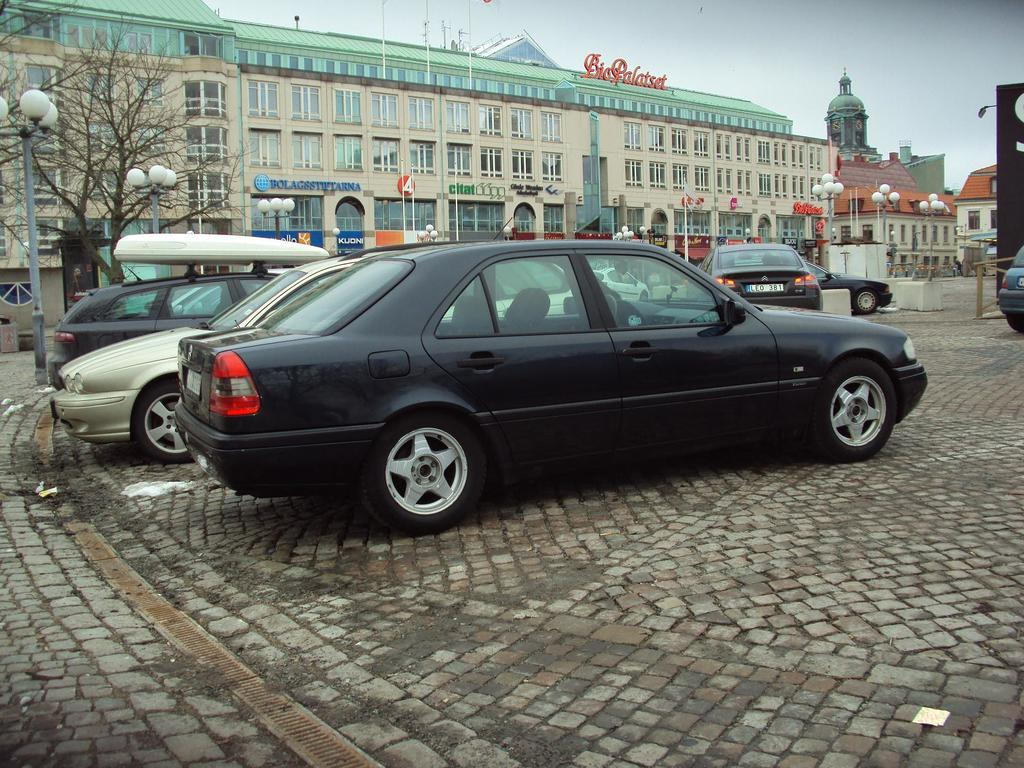What is in the center of the image? There are cars on the road in the center of the image. What can be seen in the background of the image? There are buildings, trees, lights, and the sky visible in the background of the image. What type of ship can be seen sailing in the sky in the image? There is no ship present in the image, and the sky is visible but does not contain any ships. 